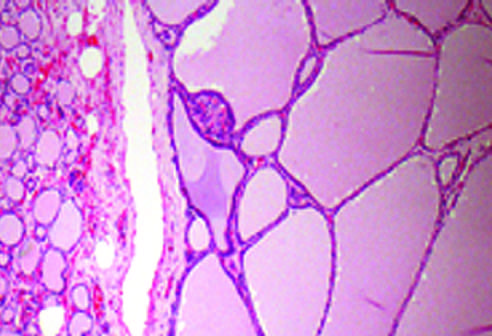the hyperplastic follicles contain abundant pink colloid within whose lumina?
Answer the question using a single word or phrase. Their 